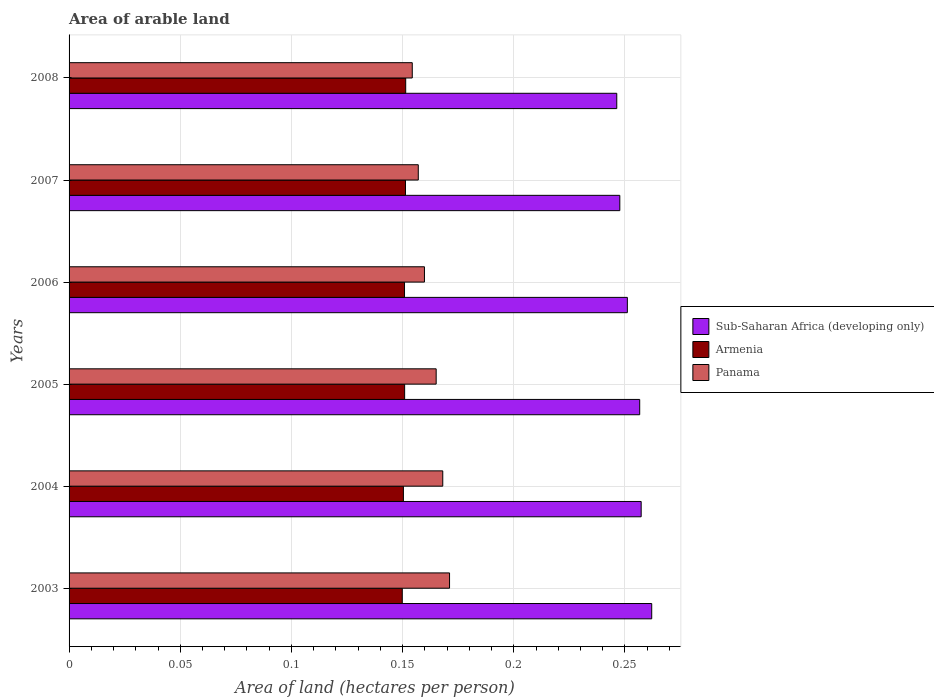How many different coloured bars are there?
Provide a succinct answer. 3. How many bars are there on the 1st tick from the bottom?
Your response must be concise. 3. What is the label of the 3rd group of bars from the top?
Give a very brief answer. 2006. In how many cases, is the number of bars for a given year not equal to the number of legend labels?
Make the answer very short. 0. What is the total arable land in Armenia in 2003?
Make the answer very short. 0.15. Across all years, what is the maximum total arable land in Panama?
Make the answer very short. 0.17. Across all years, what is the minimum total arable land in Panama?
Provide a short and direct response. 0.15. In which year was the total arable land in Panama minimum?
Make the answer very short. 2008. What is the total total arable land in Sub-Saharan Africa (developing only) in the graph?
Give a very brief answer. 1.52. What is the difference between the total arable land in Panama in 2003 and that in 2006?
Your answer should be very brief. 0.01. What is the difference between the total arable land in Armenia in 2007 and the total arable land in Panama in 2003?
Give a very brief answer. -0.02. What is the average total arable land in Armenia per year?
Give a very brief answer. 0.15. In the year 2005, what is the difference between the total arable land in Armenia and total arable land in Sub-Saharan Africa (developing only)?
Offer a terse response. -0.11. In how many years, is the total arable land in Panama greater than 0.16000000000000003 hectares per person?
Keep it short and to the point. 3. What is the ratio of the total arable land in Sub-Saharan Africa (developing only) in 2003 to that in 2005?
Ensure brevity in your answer.  1.02. What is the difference between the highest and the second highest total arable land in Sub-Saharan Africa (developing only)?
Provide a succinct answer. 0. What is the difference between the highest and the lowest total arable land in Panama?
Your answer should be very brief. 0.02. What does the 1st bar from the top in 2006 represents?
Offer a very short reply. Panama. What does the 1st bar from the bottom in 2008 represents?
Your answer should be very brief. Sub-Saharan Africa (developing only). Is it the case that in every year, the sum of the total arable land in Armenia and total arable land in Panama is greater than the total arable land in Sub-Saharan Africa (developing only)?
Make the answer very short. Yes. How many bars are there?
Give a very brief answer. 18. What is the difference between two consecutive major ticks on the X-axis?
Give a very brief answer. 0.05. Where does the legend appear in the graph?
Offer a terse response. Center right. How are the legend labels stacked?
Your answer should be very brief. Vertical. What is the title of the graph?
Offer a very short reply. Area of arable land. What is the label or title of the X-axis?
Your answer should be compact. Area of land (hectares per person). What is the Area of land (hectares per person) of Sub-Saharan Africa (developing only) in 2003?
Offer a terse response. 0.26. What is the Area of land (hectares per person) of Armenia in 2003?
Your answer should be very brief. 0.15. What is the Area of land (hectares per person) of Panama in 2003?
Keep it short and to the point. 0.17. What is the Area of land (hectares per person) in Sub-Saharan Africa (developing only) in 2004?
Your answer should be very brief. 0.26. What is the Area of land (hectares per person) in Armenia in 2004?
Your response must be concise. 0.15. What is the Area of land (hectares per person) of Panama in 2004?
Give a very brief answer. 0.17. What is the Area of land (hectares per person) of Sub-Saharan Africa (developing only) in 2005?
Offer a terse response. 0.26. What is the Area of land (hectares per person) in Armenia in 2005?
Provide a short and direct response. 0.15. What is the Area of land (hectares per person) in Panama in 2005?
Keep it short and to the point. 0.17. What is the Area of land (hectares per person) in Sub-Saharan Africa (developing only) in 2006?
Your answer should be compact. 0.25. What is the Area of land (hectares per person) of Armenia in 2006?
Your answer should be very brief. 0.15. What is the Area of land (hectares per person) of Panama in 2006?
Offer a very short reply. 0.16. What is the Area of land (hectares per person) of Sub-Saharan Africa (developing only) in 2007?
Give a very brief answer. 0.25. What is the Area of land (hectares per person) in Armenia in 2007?
Your answer should be compact. 0.15. What is the Area of land (hectares per person) of Panama in 2007?
Offer a terse response. 0.16. What is the Area of land (hectares per person) in Sub-Saharan Africa (developing only) in 2008?
Provide a short and direct response. 0.25. What is the Area of land (hectares per person) in Armenia in 2008?
Your answer should be compact. 0.15. What is the Area of land (hectares per person) of Panama in 2008?
Your answer should be very brief. 0.15. Across all years, what is the maximum Area of land (hectares per person) in Sub-Saharan Africa (developing only)?
Give a very brief answer. 0.26. Across all years, what is the maximum Area of land (hectares per person) in Armenia?
Provide a short and direct response. 0.15. Across all years, what is the maximum Area of land (hectares per person) in Panama?
Keep it short and to the point. 0.17. Across all years, what is the minimum Area of land (hectares per person) of Sub-Saharan Africa (developing only)?
Make the answer very short. 0.25. Across all years, what is the minimum Area of land (hectares per person) in Armenia?
Your response must be concise. 0.15. Across all years, what is the minimum Area of land (hectares per person) in Panama?
Provide a short and direct response. 0.15. What is the total Area of land (hectares per person) of Sub-Saharan Africa (developing only) in the graph?
Provide a succinct answer. 1.52. What is the total Area of land (hectares per person) of Armenia in the graph?
Provide a succinct answer. 0.9. What is the total Area of land (hectares per person) in Panama in the graph?
Your response must be concise. 0.98. What is the difference between the Area of land (hectares per person) of Sub-Saharan Africa (developing only) in 2003 and that in 2004?
Provide a succinct answer. 0. What is the difference between the Area of land (hectares per person) of Armenia in 2003 and that in 2004?
Provide a succinct answer. -0. What is the difference between the Area of land (hectares per person) of Panama in 2003 and that in 2004?
Offer a terse response. 0. What is the difference between the Area of land (hectares per person) of Sub-Saharan Africa (developing only) in 2003 and that in 2005?
Your response must be concise. 0.01. What is the difference between the Area of land (hectares per person) in Armenia in 2003 and that in 2005?
Your answer should be compact. -0. What is the difference between the Area of land (hectares per person) of Panama in 2003 and that in 2005?
Provide a succinct answer. 0.01. What is the difference between the Area of land (hectares per person) in Sub-Saharan Africa (developing only) in 2003 and that in 2006?
Keep it short and to the point. 0.01. What is the difference between the Area of land (hectares per person) in Armenia in 2003 and that in 2006?
Provide a succinct answer. -0. What is the difference between the Area of land (hectares per person) in Panama in 2003 and that in 2006?
Provide a short and direct response. 0.01. What is the difference between the Area of land (hectares per person) in Sub-Saharan Africa (developing only) in 2003 and that in 2007?
Provide a succinct answer. 0.01. What is the difference between the Area of land (hectares per person) in Armenia in 2003 and that in 2007?
Provide a succinct answer. -0. What is the difference between the Area of land (hectares per person) of Panama in 2003 and that in 2007?
Your answer should be very brief. 0.01. What is the difference between the Area of land (hectares per person) of Sub-Saharan Africa (developing only) in 2003 and that in 2008?
Keep it short and to the point. 0.02. What is the difference between the Area of land (hectares per person) in Armenia in 2003 and that in 2008?
Provide a short and direct response. -0. What is the difference between the Area of land (hectares per person) in Panama in 2003 and that in 2008?
Keep it short and to the point. 0.02. What is the difference between the Area of land (hectares per person) in Sub-Saharan Africa (developing only) in 2004 and that in 2005?
Ensure brevity in your answer.  0. What is the difference between the Area of land (hectares per person) of Armenia in 2004 and that in 2005?
Make the answer very short. -0. What is the difference between the Area of land (hectares per person) in Panama in 2004 and that in 2005?
Your response must be concise. 0. What is the difference between the Area of land (hectares per person) of Sub-Saharan Africa (developing only) in 2004 and that in 2006?
Offer a very short reply. 0.01. What is the difference between the Area of land (hectares per person) of Armenia in 2004 and that in 2006?
Provide a short and direct response. -0. What is the difference between the Area of land (hectares per person) of Panama in 2004 and that in 2006?
Keep it short and to the point. 0.01. What is the difference between the Area of land (hectares per person) in Sub-Saharan Africa (developing only) in 2004 and that in 2007?
Give a very brief answer. 0.01. What is the difference between the Area of land (hectares per person) in Armenia in 2004 and that in 2007?
Offer a terse response. -0. What is the difference between the Area of land (hectares per person) in Panama in 2004 and that in 2007?
Your response must be concise. 0.01. What is the difference between the Area of land (hectares per person) of Sub-Saharan Africa (developing only) in 2004 and that in 2008?
Offer a terse response. 0.01. What is the difference between the Area of land (hectares per person) in Armenia in 2004 and that in 2008?
Make the answer very short. -0. What is the difference between the Area of land (hectares per person) of Panama in 2004 and that in 2008?
Your answer should be compact. 0.01. What is the difference between the Area of land (hectares per person) of Sub-Saharan Africa (developing only) in 2005 and that in 2006?
Provide a short and direct response. 0.01. What is the difference between the Area of land (hectares per person) of Panama in 2005 and that in 2006?
Offer a terse response. 0.01. What is the difference between the Area of land (hectares per person) of Sub-Saharan Africa (developing only) in 2005 and that in 2007?
Your answer should be very brief. 0.01. What is the difference between the Area of land (hectares per person) of Armenia in 2005 and that in 2007?
Provide a short and direct response. -0. What is the difference between the Area of land (hectares per person) in Panama in 2005 and that in 2007?
Your answer should be very brief. 0.01. What is the difference between the Area of land (hectares per person) of Sub-Saharan Africa (developing only) in 2005 and that in 2008?
Your answer should be compact. 0.01. What is the difference between the Area of land (hectares per person) in Armenia in 2005 and that in 2008?
Ensure brevity in your answer.  -0. What is the difference between the Area of land (hectares per person) in Panama in 2005 and that in 2008?
Make the answer very short. 0.01. What is the difference between the Area of land (hectares per person) of Sub-Saharan Africa (developing only) in 2006 and that in 2007?
Your response must be concise. 0. What is the difference between the Area of land (hectares per person) of Armenia in 2006 and that in 2007?
Give a very brief answer. -0. What is the difference between the Area of land (hectares per person) of Panama in 2006 and that in 2007?
Keep it short and to the point. 0. What is the difference between the Area of land (hectares per person) of Sub-Saharan Africa (developing only) in 2006 and that in 2008?
Your answer should be compact. 0. What is the difference between the Area of land (hectares per person) in Armenia in 2006 and that in 2008?
Keep it short and to the point. -0. What is the difference between the Area of land (hectares per person) of Panama in 2006 and that in 2008?
Provide a succinct answer. 0.01. What is the difference between the Area of land (hectares per person) of Sub-Saharan Africa (developing only) in 2007 and that in 2008?
Provide a succinct answer. 0. What is the difference between the Area of land (hectares per person) of Armenia in 2007 and that in 2008?
Offer a terse response. -0. What is the difference between the Area of land (hectares per person) in Panama in 2007 and that in 2008?
Provide a succinct answer. 0. What is the difference between the Area of land (hectares per person) of Sub-Saharan Africa (developing only) in 2003 and the Area of land (hectares per person) of Armenia in 2004?
Your response must be concise. 0.11. What is the difference between the Area of land (hectares per person) in Sub-Saharan Africa (developing only) in 2003 and the Area of land (hectares per person) in Panama in 2004?
Offer a very short reply. 0.09. What is the difference between the Area of land (hectares per person) of Armenia in 2003 and the Area of land (hectares per person) of Panama in 2004?
Give a very brief answer. -0.02. What is the difference between the Area of land (hectares per person) in Sub-Saharan Africa (developing only) in 2003 and the Area of land (hectares per person) in Armenia in 2005?
Ensure brevity in your answer.  0.11. What is the difference between the Area of land (hectares per person) of Sub-Saharan Africa (developing only) in 2003 and the Area of land (hectares per person) of Panama in 2005?
Keep it short and to the point. 0.1. What is the difference between the Area of land (hectares per person) of Armenia in 2003 and the Area of land (hectares per person) of Panama in 2005?
Offer a terse response. -0.02. What is the difference between the Area of land (hectares per person) of Sub-Saharan Africa (developing only) in 2003 and the Area of land (hectares per person) of Armenia in 2006?
Your answer should be compact. 0.11. What is the difference between the Area of land (hectares per person) in Sub-Saharan Africa (developing only) in 2003 and the Area of land (hectares per person) in Panama in 2006?
Offer a terse response. 0.1. What is the difference between the Area of land (hectares per person) in Armenia in 2003 and the Area of land (hectares per person) in Panama in 2006?
Keep it short and to the point. -0.01. What is the difference between the Area of land (hectares per person) in Sub-Saharan Africa (developing only) in 2003 and the Area of land (hectares per person) in Armenia in 2007?
Keep it short and to the point. 0.11. What is the difference between the Area of land (hectares per person) of Sub-Saharan Africa (developing only) in 2003 and the Area of land (hectares per person) of Panama in 2007?
Give a very brief answer. 0.1. What is the difference between the Area of land (hectares per person) in Armenia in 2003 and the Area of land (hectares per person) in Panama in 2007?
Give a very brief answer. -0.01. What is the difference between the Area of land (hectares per person) in Sub-Saharan Africa (developing only) in 2003 and the Area of land (hectares per person) in Armenia in 2008?
Give a very brief answer. 0.11. What is the difference between the Area of land (hectares per person) in Sub-Saharan Africa (developing only) in 2003 and the Area of land (hectares per person) in Panama in 2008?
Offer a very short reply. 0.11. What is the difference between the Area of land (hectares per person) of Armenia in 2003 and the Area of land (hectares per person) of Panama in 2008?
Offer a terse response. -0. What is the difference between the Area of land (hectares per person) of Sub-Saharan Africa (developing only) in 2004 and the Area of land (hectares per person) of Armenia in 2005?
Ensure brevity in your answer.  0.11. What is the difference between the Area of land (hectares per person) in Sub-Saharan Africa (developing only) in 2004 and the Area of land (hectares per person) in Panama in 2005?
Keep it short and to the point. 0.09. What is the difference between the Area of land (hectares per person) in Armenia in 2004 and the Area of land (hectares per person) in Panama in 2005?
Offer a very short reply. -0.01. What is the difference between the Area of land (hectares per person) in Sub-Saharan Africa (developing only) in 2004 and the Area of land (hectares per person) in Armenia in 2006?
Keep it short and to the point. 0.11. What is the difference between the Area of land (hectares per person) of Sub-Saharan Africa (developing only) in 2004 and the Area of land (hectares per person) of Panama in 2006?
Offer a very short reply. 0.1. What is the difference between the Area of land (hectares per person) in Armenia in 2004 and the Area of land (hectares per person) in Panama in 2006?
Your answer should be very brief. -0.01. What is the difference between the Area of land (hectares per person) in Sub-Saharan Africa (developing only) in 2004 and the Area of land (hectares per person) in Armenia in 2007?
Your answer should be compact. 0.11. What is the difference between the Area of land (hectares per person) in Sub-Saharan Africa (developing only) in 2004 and the Area of land (hectares per person) in Panama in 2007?
Keep it short and to the point. 0.1. What is the difference between the Area of land (hectares per person) of Armenia in 2004 and the Area of land (hectares per person) of Panama in 2007?
Make the answer very short. -0.01. What is the difference between the Area of land (hectares per person) in Sub-Saharan Africa (developing only) in 2004 and the Area of land (hectares per person) in Armenia in 2008?
Keep it short and to the point. 0.11. What is the difference between the Area of land (hectares per person) of Sub-Saharan Africa (developing only) in 2004 and the Area of land (hectares per person) of Panama in 2008?
Ensure brevity in your answer.  0.1. What is the difference between the Area of land (hectares per person) of Armenia in 2004 and the Area of land (hectares per person) of Panama in 2008?
Provide a succinct answer. -0. What is the difference between the Area of land (hectares per person) in Sub-Saharan Africa (developing only) in 2005 and the Area of land (hectares per person) in Armenia in 2006?
Give a very brief answer. 0.11. What is the difference between the Area of land (hectares per person) in Sub-Saharan Africa (developing only) in 2005 and the Area of land (hectares per person) in Panama in 2006?
Ensure brevity in your answer.  0.1. What is the difference between the Area of land (hectares per person) in Armenia in 2005 and the Area of land (hectares per person) in Panama in 2006?
Provide a succinct answer. -0.01. What is the difference between the Area of land (hectares per person) in Sub-Saharan Africa (developing only) in 2005 and the Area of land (hectares per person) in Armenia in 2007?
Ensure brevity in your answer.  0.11. What is the difference between the Area of land (hectares per person) in Sub-Saharan Africa (developing only) in 2005 and the Area of land (hectares per person) in Panama in 2007?
Make the answer very short. 0.1. What is the difference between the Area of land (hectares per person) of Armenia in 2005 and the Area of land (hectares per person) of Panama in 2007?
Ensure brevity in your answer.  -0.01. What is the difference between the Area of land (hectares per person) of Sub-Saharan Africa (developing only) in 2005 and the Area of land (hectares per person) of Armenia in 2008?
Make the answer very short. 0.11. What is the difference between the Area of land (hectares per person) of Sub-Saharan Africa (developing only) in 2005 and the Area of land (hectares per person) of Panama in 2008?
Provide a succinct answer. 0.1. What is the difference between the Area of land (hectares per person) in Armenia in 2005 and the Area of land (hectares per person) in Panama in 2008?
Your response must be concise. -0. What is the difference between the Area of land (hectares per person) of Sub-Saharan Africa (developing only) in 2006 and the Area of land (hectares per person) of Armenia in 2007?
Keep it short and to the point. 0.1. What is the difference between the Area of land (hectares per person) in Sub-Saharan Africa (developing only) in 2006 and the Area of land (hectares per person) in Panama in 2007?
Offer a terse response. 0.09. What is the difference between the Area of land (hectares per person) in Armenia in 2006 and the Area of land (hectares per person) in Panama in 2007?
Keep it short and to the point. -0.01. What is the difference between the Area of land (hectares per person) in Sub-Saharan Africa (developing only) in 2006 and the Area of land (hectares per person) in Armenia in 2008?
Make the answer very short. 0.1. What is the difference between the Area of land (hectares per person) in Sub-Saharan Africa (developing only) in 2006 and the Area of land (hectares per person) in Panama in 2008?
Give a very brief answer. 0.1. What is the difference between the Area of land (hectares per person) of Armenia in 2006 and the Area of land (hectares per person) of Panama in 2008?
Make the answer very short. -0. What is the difference between the Area of land (hectares per person) in Sub-Saharan Africa (developing only) in 2007 and the Area of land (hectares per person) in Armenia in 2008?
Keep it short and to the point. 0.1. What is the difference between the Area of land (hectares per person) in Sub-Saharan Africa (developing only) in 2007 and the Area of land (hectares per person) in Panama in 2008?
Give a very brief answer. 0.09. What is the difference between the Area of land (hectares per person) of Armenia in 2007 and the Area of land (hectares per person) of Panama in 2008?
Your answer should be very brief. -0. What is the average Area of land (hectares per person) of Sub-Saharan Africa (developing only) per year?
Provide a succinct answer. 0.25. What is the average Area of land (hectares per person) in Armenia per year?
Provide a succinct answer. 0.15. What is the average Area of land (hectares per person) of Panama per year?
Make the answer very short. 0.16. In the year 2003, what is the difference between the Area of land (hectares per person) of Sub-Saharan Africa (developing only) and Area of land (hectares per person) of Armenia?
Provide a short and direct response. 0.11. In the year 2003, what is the difference between the Area of land (hectares per person) in Sub-Saharan Africa (developing only) and Area of land (hectares per person) in Panama?
Give a very brief answer. 0.09. In the year 2003, what is the difference between the Area of land (hectares per person) of Armenia and Area of land (hectares per person) of Panama?
Keep it short and to the point. -0.02. In the year 2004, what is the difference between the Area of land (hectares per person) in Sub-Saharan Africa (developing only) and Area of land (hectares per person) in Armenia?
Offer a very short reply. 0.11. In the year 2004, what is the difference between the Area of land (hectares per person) in Sub-Saharan Africa (developing only) and Area of land (hectares per person) in Panama?
Provide a short and direct response. 0.09. In the year 2004, what is the difference between the Area of land (hectares per person) in Armenia and Area of land (hectares per person) in Panama?
Your answer should be compact. -0.02. In the year 2005, what is the difference between the Area of land (hectares per person) in Sub-Saharan Africa (developing only) and Area of land (hectares per person) in Armenia?
Make the answer very short. 0.11. In the year 2005, what is the difference between the Area of land (hectares per person) of Sub-Saharan Africa (developing only) and Area of land (hectares per person) of Panama?
Your answer should be very brief. 0.09. In the year 2005, what is the difference between the Area of land (hectares per person) in Armenia and Area of land (hectares per person) in Panama?
Your answer should be very brief. -0.01. In the year 2006, what is the difference between the Area of land (hectares per person) in Sub-Saharan Africa (developing only) and Area of land (hectares per person) in Armenia?
Give a very brief answer. 0.1. In the year 2006, what is the difference between the Area of land (hectares per person) of Sub-Saharan Africa (developing only) and Area of land (hectares per person) of Panama?
Offer a terse response. 0.09. In the year 2006, what is the difference between the Area of land (hectares per person) of Armenia and Area of land (hectares per person) of Panama?
Make the answer very short. -0.01. In the year 2007, what is the difference between the Area of land (hectares per person) of Sub-Saharan Africa (developing only) and Area of land (hectares per person) of Armenia?
Give a very brief answer. 0.1. In the year 2007, what is the difference between the Area of land (hectares per person) in Sub-Saharan Africa (developing only) and Area of land (hectares per person) in Panama?
Ensure brevity in your answer.  0.09. In the year 2007, what is the difference between the Area of land (hectares per person) in Armenia and Area of land (hectares per person) in Panama?
Make the answer very short. -0.01. In the year 2008, what is the difference between the Area of land (hectares per person) in Sub-Saharan Africa (developing only) and Area of land (hectares per person) in Armenia?
Offer a terse response. 0.09. In the year 2008, what is the difference between the Area of land (hectares per person) in Sub-Saharan Africa (developing only) and Area of land (hectares per person) in Panama?
Provide a short and direct response. 0.09. In the year 2008, what is the difference between the Area of land (hectares per person) in Armenia and Area of land (hectares per person) in Panama?
Provide a short and direct response. -0. What is the ratio of the Area of land (hectares per person) of Sub-Saharan Africa (developing only) in 2003 to that in 2004?
Offer a terse response. 1.02. What is the ratio of the Area of land (hectares per person) of Armenia in 2003 to that in 2004?
Your answer should be very brief. 1. What is the ratio of the Area of land (hectares per person) in Panama in 2003 to that in 2004?
Give a very brief answer. 1.02. What is the ratio of the Area of land (hectares per person) of Sub-Saharan Africa (developing only) in 2003 to that in 2005?
Keep it short and to the point. 1.02. What is the ratio of the Area of land (hectares per person) in Armenia in 2003 to that in 2005?
Your answer should be very brief. 0.99. What is the ratio of the Area of land (hectares per person) in Panama in 2003 to that in 2005?
Give a very brief answer. 1.04. What is the ratio of the Area of land (hectares per person) in Sub-Saharan Africa (developing only) in 2003 to that in 2006?
Ensure brevity in your answer.  1.04. What is the ratio of the Area of land (hectares per person) of Panama in 2003 to that in 2006?
Offer a very short reply. 1.07. What is the ratio of the Area of land (hectares per person) in Sub-Saharan Africa (developing only) in 2003 to that in 2007?
Provide a short and direct response. 1.06. What is the ratio of the Area of land (hectares per person) in Panama in 2003 to that in 2007?
Provide a succinct answer. 1.09. What is the ratio of the Area of land (hectares per person) in Sub-Saharan Africa (developing only) in 2003 to that in 2008?
Your answer should be very brief. 1.06. What is the ratio of the Area of land (hectares per person) of Armenia in 2003 to that in 2008?
Offer a terse response. 0.99. What is the ratio of the Area of land (hectares per person) in Panama in 2003 to that in 2008?
Provide a succinct answer. 1.11. What is the ratio of the Area of land (hectares per person) of Sub-Saharan Africa (developing only) in 2004 to that in 2005?
Give a very brief answer. 1. What is the ratio of the Area of land (hectares per person) of Armenia in 2004 to that in 2005?
Provide a short and direct response. 1. What is the ratio of the Area of land (hectares per person) of Sub-Saharan Africa (developing only) in 2004 to that in 2006?
Give a very brief answer. 1.02. What is the ratio of the Area of land (hectares per person) in Panama in 2004 to that in 2006?
Offer a terse response. 1.05. What is the ratio of the Area of land (hectares per person) of Sub-Saharan Africa (developing only) in 2004 to that in 2007?
Your answer should be very brief. 1.04. What is the ratio of the Area of land (hectares per person) of Panama in 2004 to that in 2007?
Offer a very short reply. 1.07. What is the ratio of the Area of land (hectares per person) in Sub-Saharan Africa (developing only) in 2004 to that in 2008?
Offer a very short reply. 1.04. What is the ratio of the Area of land (hectares per person) in Panama in 2004 to that in 2008?
Your answer should be very brief. 1.09. What is the ratio of the Area of land (hectares per person) in Sub-Saharan Africa (developing only) in 2005 to that in 2006?
Provide a succinct answer. 1.02. What is the ratio of the Area of land (hectares per person) in Panama in 2005 to that in 2006?
Your response must be concise. 1.03. What is the ratio of the Area of land (hectares per person) in Sub-Saharan Africa (developing only) in 2005 to that in 2007?
Provide a succinct answer. 1.04. What is the ratio of the Area of land (hectares per person) in Panama in 2005 to that in 2007?
Provide a succinct answer. 1.05. What is the ratio of the Area of land (hectares per person) in Sub-Saharan Africa (developing only) in 2005 to that in 2008?
Your answer should be compact. 1.04. What is the ratio of the Area of land (hectares per person) in Panama in 2005 to that in 2008?
Provide a short and direct response. 1.07. What is the ratio of the Area of land (hectares per person) of Sub-Saharan Africa (developing only) in 2006 to that in 2007?
Your response must be concise. 1.01. What is the ratio of the Area of land (hectares per person) in Panama in 2006 to that in 2007?
Your answer should be compact. 1.02. What is the ratio of the Area of land (hectares per person) in Sub-Saharan Africa (developing only) in 2006 to that in 2008?
Keep it short and to the point. 1.02. What is the ratio of the Area of land (hectares per person) of Armenia in 2006 to that in 2008?
Your answer should be very brief. 1. What is the ratio of the Area of land (hectares per person) of Panama in 2006 to that in 2008?
Give a very brief answer. 1.04. What is the ratio of the Area of land (hectares per person) in Sub-Saharan Africa (developing only) in 2007 to that in 2008?
Keep it short and to the point. 1.01. What is the ratio of the Area of land (hectares per person) of Panama in 2007 to that in 2008?
Make the answer very short. 1.02. What is the difference between the highest and the second highest Area of land (hectares per person) of Sub-Saharan Africa (developing only)?
Offer a terse response. 0. What is the difference between the highest and the second highest Area of land (hectares per person) of Armenia?
Ensure brevity in your answer.  0. What is the difference between the highest and the second highest Area of land (hectares per person) of Panama?
Provide a short and direct response. 0. What is the difference between the highest and the lowest Area of land (hectares per person) of Sub-Saharan Africa (developing only)?
Give a very brief answer. 0.02. What is the difference between the highest and the lowest Area of land (hectares per person) in Armenia?
Your response must be concise. 0. What is the difference between the highest and the lowest Area of land (hectares per person) in Panama?
Provide a short and direct response. 0.02. 